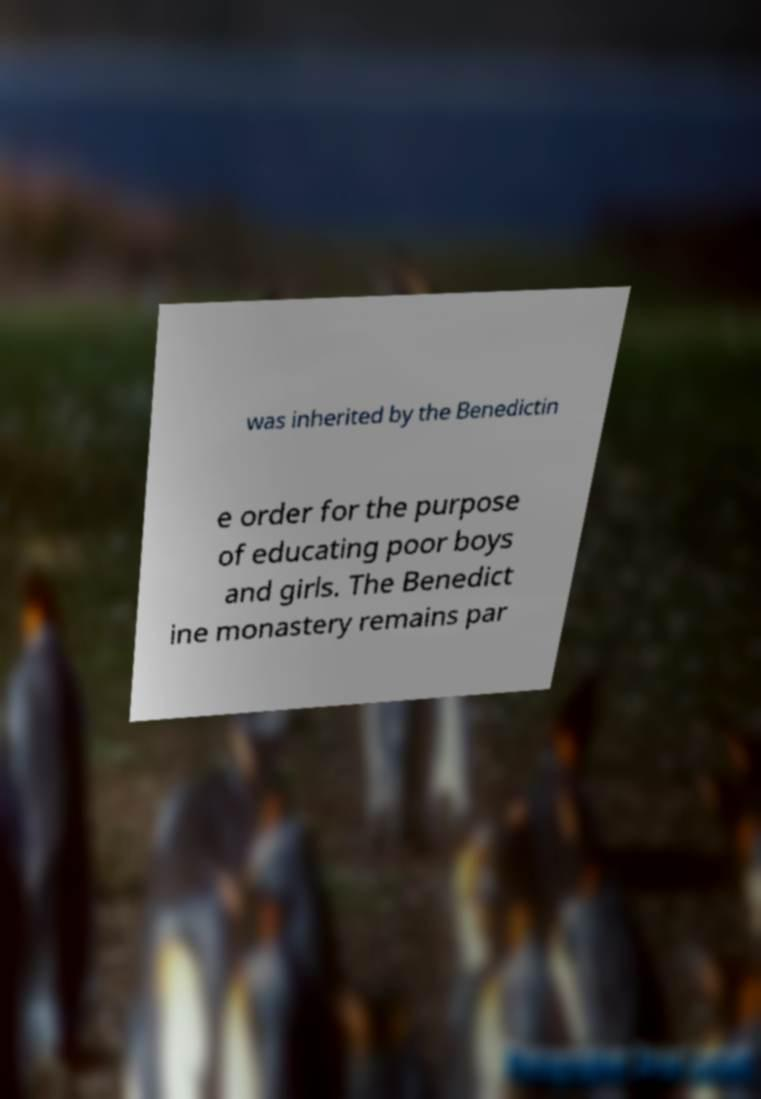I need the written content from this picture converted into text. Can you do that? was inherited by the Benedictin e order for the purpose of educating poor boys and girls. The Benedict ine monastery remains par 